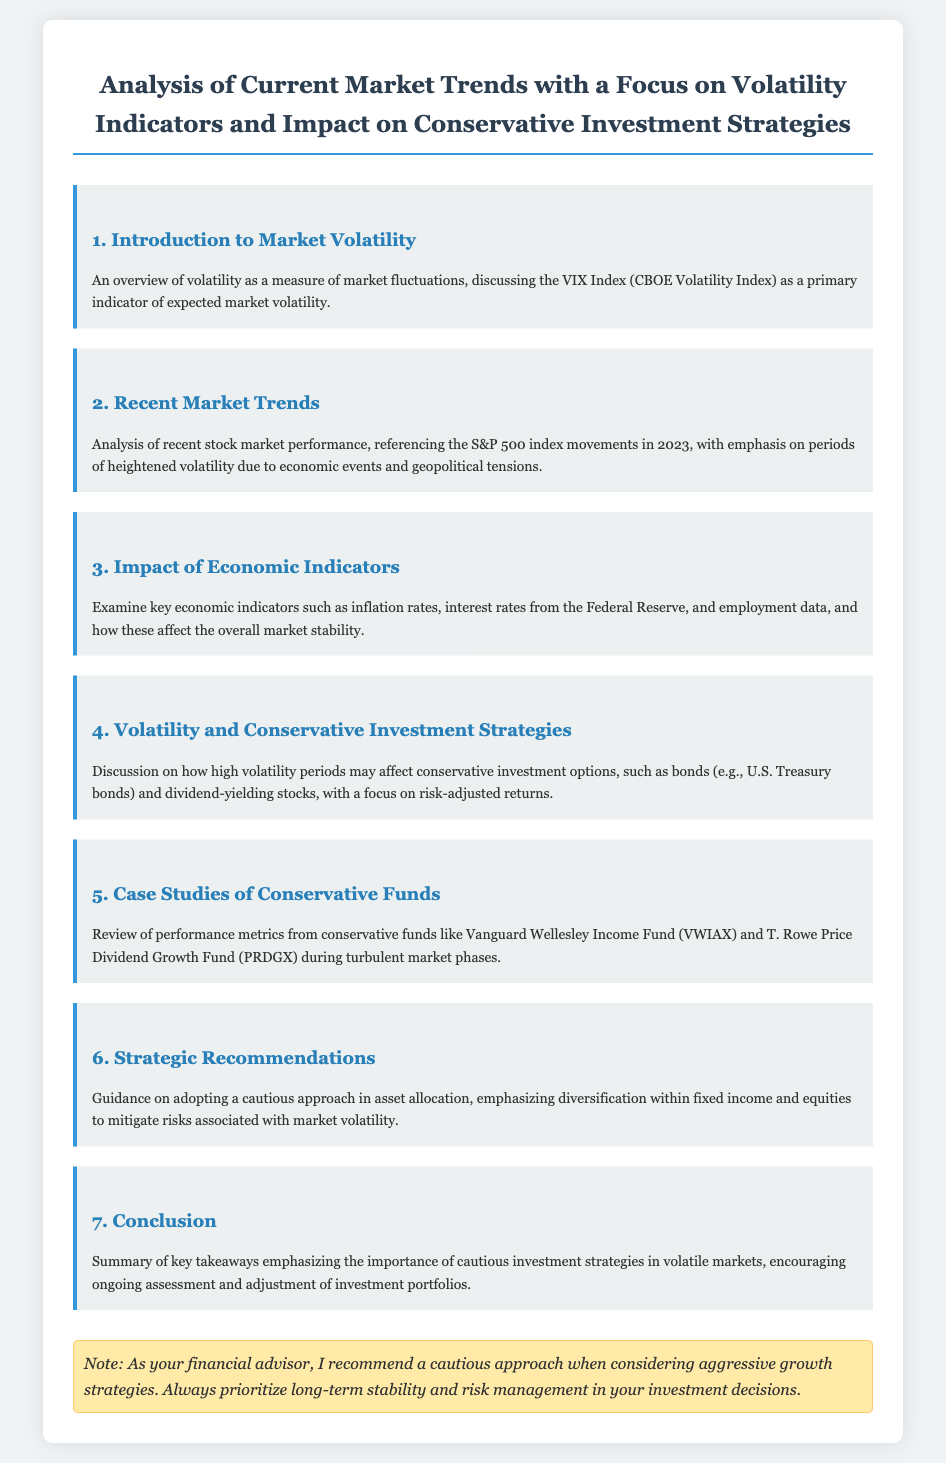what is the main focus of the analysis? The main focus is on volatility indicators and the impact on conservative investment strategies.
Answer: volatility indicators and impact on conservative investment strategies what is the primary indicator of expected market volatility mentioned? The primary indicator discussed in the document is the VIX Index, which measures expected market volatility.
Answer: VIX Index which index movements are referenced in the recent market trends section? The document references the S&P 500 index movements during 2023.
Answer: S&P 500 what do high volatility periods affect according to the document? High volatility periods may affect conservative investment options, such as bonds and dividend-yielding stocks.
Answer: conservative investment options which funds are reviewed in the case studies section? The review includes performance metrics from Vanguard Wellesley Income Fund and T. Rowe Price Dividend Growth Fund.
Answer: Vanguard Wellesley Income Fund and T. Rowe Price Dividend Growth Fund what does the strategic recommendations section emphasize? It emphasizes a cautious approach in asset allocation and risk mitigation.
Answer: cautious approach in asset allocation what is the caution note that the financial advisor recommends? The advisor recommends prioritizing long-term stability and risk management over aggressive growth strategies.
Answer: prioritizing long-term stability and risk management 